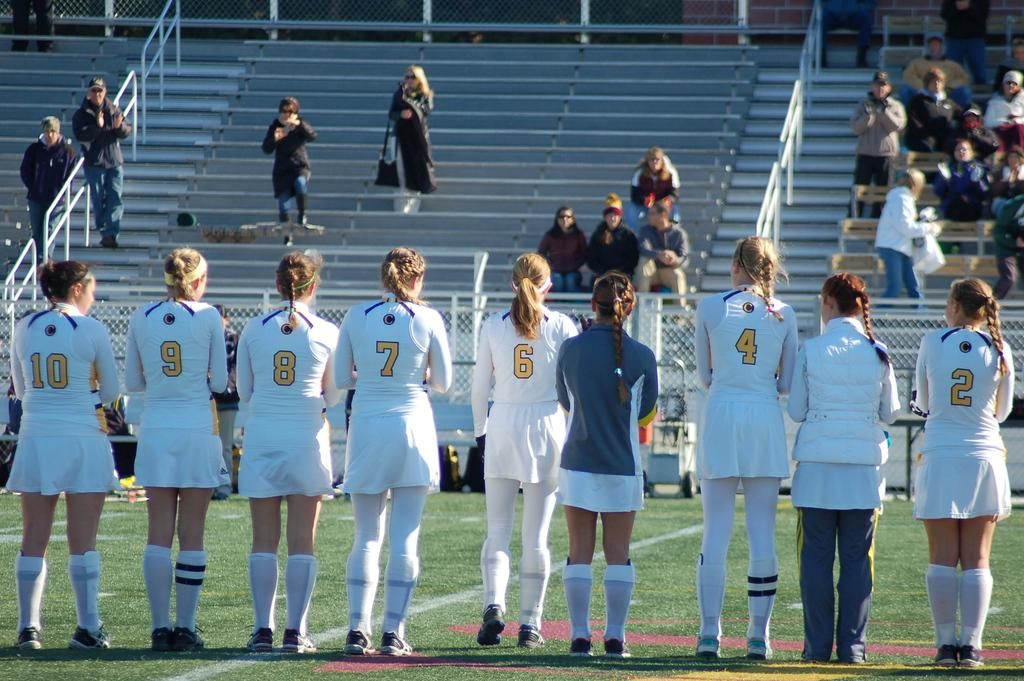<image>
Write a terse but informative summary of the picture. A line of female players wearing white jerseys stand on the field with numbers 10 and 2 on the ends 